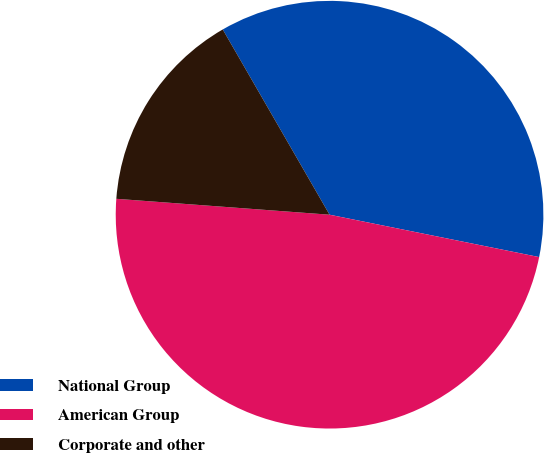Convert chart to OTSL. <chart><loc_0><loc_0><loc_500><loc_500><pie_chart><fcel>National Group<fcel>American Group<fcel>Corporate and other<nl><fcel>36.5%<fcel>48.01%<fcel>15.49%<nl></chart> 